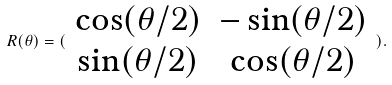<formula> <loc_0><loc_0><loc_500><loc_500>R ( \theta ) = ( \begin{array} { c c } \cos ( \theta / 2 ) & - \sin ( \theta / 2 ) \\ \sin ( \theta / 2 ) & \cos ( \theta / 2 ) \end{array} ) .</formula> 